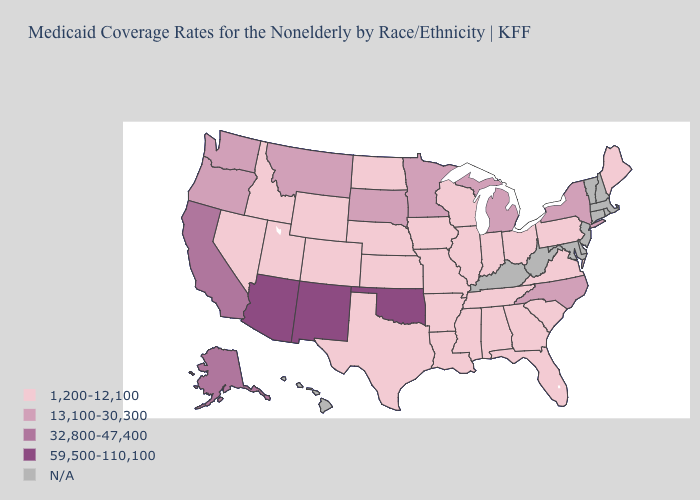Among the states that border Utah , does Wyoming have the lowest value?
Give a very brief answer. Yes. Does Arizona have the highest value in the USA?
Be succinct. Yes. Does Arizona have the highest value in the West?
Short answer required. Yes. Name the states that have a value in the range 59,500-110,100?
Quick response, please. Arizona, New Mexico, Oklahoma. What is the lowest value in the USA?
Write a very short answer. 1,200-12,100. Which states have the lowest value in the USA?
Be succinct. Alabama, Arkansas, Colorado, Florida, Georgia, Idaho, Illinois, Indiana, Iowa, Kansas, Louisiana, Maine, Mississippi, Missouri, Nebraska, Nevada, North Dakota, Ohio, Pennsylvania, South Carolina, Tennessee, Texas, Utah, Virginia, Wisconsin, Wyoming. What is the value of Washington?
Keep it brief. 13,100-30,300. Name the states that have a value in the range 13,100-30,300?
Keep it brief. Michigan, Minnesota, Montana, New York, North Carolina, Oregon, South Dakota, Washington. Does California have the lowest value in the USA?
Be succinct. No. Does Washington have the lowest value in the USA?
Write a very short answer. No. What is the lowest value in states that border California?
Short answer required. 1,200-12,100. Name the states that have a value in the range 1,200-12,100?
Answer briefly. Alabama, Arkansas, Colorado, Florida, Georgia, Idaho, Illinois, Indiana, Iowa, Kansas, Louisiana, Maine, Mississippi, Missouri, Nebraska, Nevada, North Dakota, Ohio, Pennsylvania, South Carolina, Tennessee, Texas, Utah, Virginia, Wisconsin, Wyoming. 